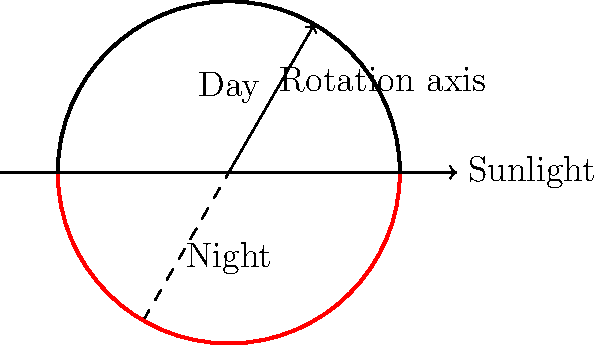As a factory supervisor who values efficient operations, consider the Earth's rotation and its impact on productivity. If the Earth were to suddenly stop rotating, how would this affect the day-night cycle, and what potential challenges might this pose for maintaining consistent production schedules across different regions? To understand the impact of Earth's rotation on day-night cycles and productivity, let's break it down step-by-step:

1. Earth's current rotation:
   - The Earth rotates on its axis once every 24 hours, causing day and night cycles.
   - This rotation creates a consistent pattern of light and dark periods for most locations on Earth.

2. If Earth stopped rotating:
   - One side of the Earth would always face the Sun, experiencing perpetual daylight.
   - The opposite side would be in constant darkness.
   - The day-night cycle as we know it would cease to exist.

3. Impact on day-night cycle:
   - Instead of rotating regions experiencing alternating periods of light and dark, we'd have fixed "day" and "night" sides of the planet.
   - The terminator line (the boundary between day and night) would become stationary.

4. Challenges for production schedules:
   a) Constant daylight regions:
      - Potential for continuous production, but issues with worker fatigue and health due to lack of natural night-day cycles.
      - Possible overheating and increased energy costs for cooling systems.

   b) Constant darkness regions:
      - Need for constant artificial lighting, increasing energy costs.
      - Potential negative impacts on worker morale and productivity due to lack of natural light.

   c) Terminator regions:
      - These areas might experience perpetual twilight, presenting unique lighting challenges.

5. Global production implications:
   - Impossible to maintain consistent global production schedules based on day-night cycles.
   - Need for a complete reorganization of shift patterns and working hours.
   - Potential for increased reliance on automation in extreme light/dark regions.

6. Communication and coordination challenges:
   - Difficulty in maintaining regular communication schedules between different regions due to the lack of shared day-night experiences.
   - Potential need for new global time-keeping systems not based on Earth's rotation.

In conclusion, the cessation of Earth's rotation would dramatically alter the day-night cycle, creating significant challenges for maintaining consistent production schedules across different regions. This scenario would necessitate a complete rethinking of global industrial operations and worker management practices.
Answer: Permanent day and night sides, requiring complete reorganization of global production schedules and worker management practices. 